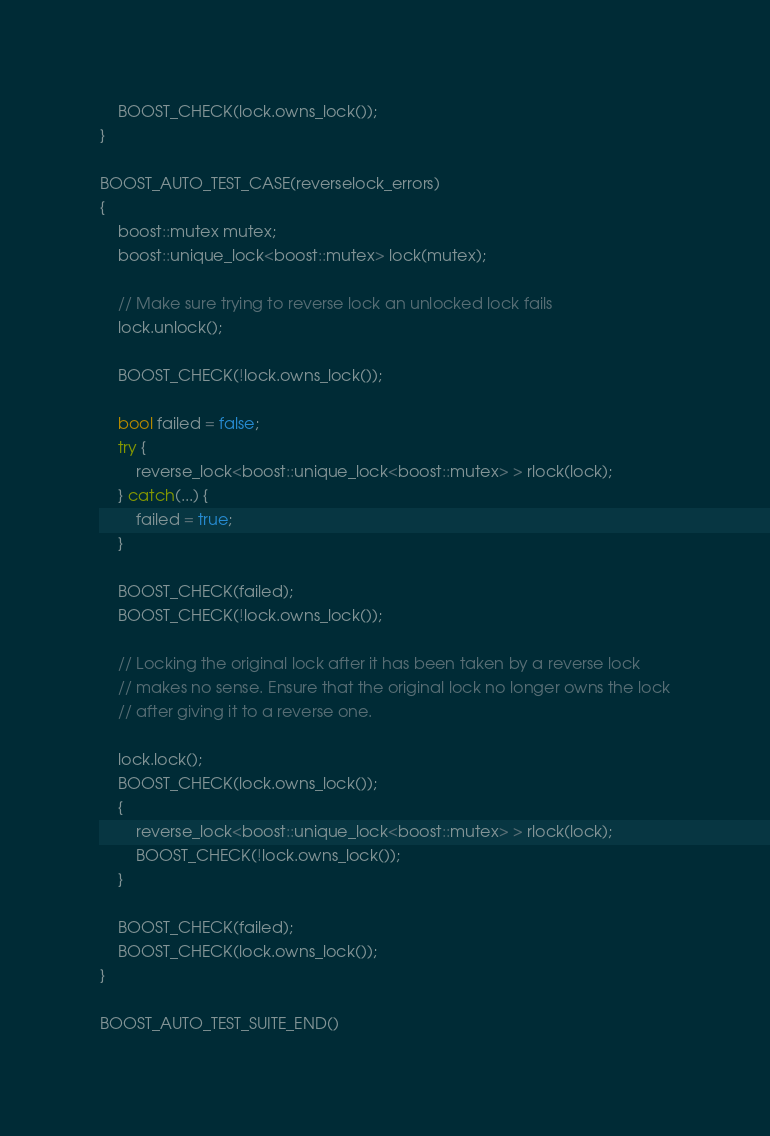Convert code to text. <code><loc_0><loc_0><loc_500><loc_500><_C++_>    BOOST_CHECK(lock.owns_lock());
}

BOOST_AUTO_TEST_CASE(reverselock_errors)
{
    boost::mutex mutex;
    boost::unique_lock<boost::mutex> lock(mutex);

    // Make sure trying to reverse lock an unlocked lock fails
    lock.unlock();

    BOOST_CHECK(!lock.owns_lock());

    bool failed = false;
    try {
        reverse_lock<boost::unique_lock<boost::mutex> > rlock(lock);
    } catch(...) {
        failed = true;
    }

    BOOST_CHECK(failed);
    BOOST_CHECK(!lock.owns_lock());

    // Locking the original lock after it has been taken by a reverse lock
    // makes no sense. Ensure that the original lock no longer owns the lock
    // after giving it to a reverse one.

    lock.lock();
    BOOST_CHECK(lock.owns_lock());
    {
        reverse_lock<boost::unique_lock<boost::mutex> > rlock(lock);
        BOOST_CHECK(!lock.owns_lock());
    }

    BOOST_CHECK(failed);
    BOOST_CHECK(lock.owns_lock());
}

BOOST_AUTO_TEST_SUITE_END()
</code> 